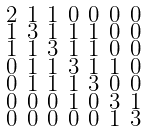<formula> <loc_0><loc_0><loc_500><loc_500>\begin{smallmatrix} 2 & 1 & 1 & 0 & 0 & 0 & 0 \\ 1 & 3 & 1 & 1 & 1 & 0 & 0 \\ 1 & 1 & 3 & 1 & 1 & 0 & 0 \\ 0 & 1 & 1 & 3 & 1 & 1 & 0 \\ 0 & 1 & 1 & 1 & 3 & 0 & 0 \\ 0 & 0 & 0 & 1 & 0 & 3 & 1 \\ 0 & 0 & 0 & 0 & 0 & 1 & 3 \end{smallmatrix}</formula> 